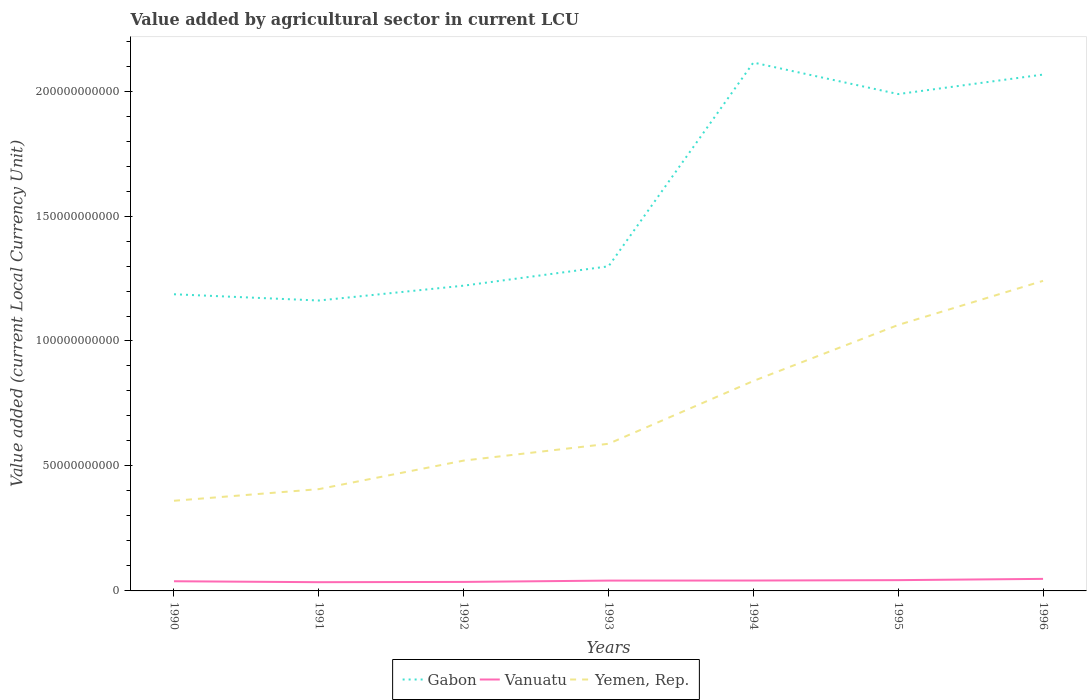Does the line corresponding to Vanuatu intersect with the line corresponding to Gabon?
Make the answer very short. No. Across all years, what is the maximum value added by agricultural sector in Vanuatu?
Give a very brief answer. 3.49e+09. What is the total value added by agricultural sector in Yemen, Rep. in the graph?
Offer a very short reply. -4.66e+09. What is the difference between the highest and the second highest value added by agricultural sector in Yemen, Rep.?
Offer a very short reply. 8.80e+1. What is the difference between the highest and the lowest value added by agricultural sector in Yemen, Rep.?
Make the answer very short. 3. Is the value added by agricultural sector in Gabon strictly greater than the value added by agricultural sector in Vanuatu over the years?
Your response must be concise. No. What is the difference between two consecutive major ticks on the Y-axis?
Provide a short and direct response. 5.00e+1. Are the values on the major ticks of Y-axis written in scientific E-notation?
Your answer should be compact. No. Does the graph contain grids?
Your answer should be compact. No. How are the legend labels stacked?
Offer a terse response. Horizontal. What is the title of the graph?
Provide a succinct answer. Value added by agricultural sector in current LCU. Does "Macedonia" appear as one of the legend labels in the graph?
Give a very brief answer. No. What is the label or title of the Y-axis?
Your response must be concise. Value added (current Local Currency Unit). What is the Value added (current Local Currency Unit) in Gabon in 1990?
Your response must be concise. 1.19e+11. What is the Value added (current Local Currency Unit) of Vanuatu in 1990?
Offer a terse response. 3.87e+09. What is the Value added (current Local Currency Unit) of Yemen, Rep. in 1990?
Offer a very short reply. 3.61e+1. What is the Value added (current Local Currency Unit) of Gabon in 1991?
Offer a terse response. 1.16e+11. What is the Value added (current Local Currency Unit) in Vanuatu in 1991?
Your answer should be compact. 3.49e+09. What is the Value added (current Local Currency Unit) in Yemen, Rep. in 1991?
Ensure brevity in your answer.  4.07e+1. What is the Value added (current Local Currency Unit) in Gabon in 1992?
Keep it short and to the point. 1.22e+11. What is the Value added (current Local Currency Unit) of Vanuatu in 1992?
Offer a terse response. 3.60e+09. What is the Value added (current Local Currency Unit) of Yemen, Rep. in 1992?
Provide a succinct answer. 5.21e+1. What is the Value added (current Local Currency Unit) in Gabon in 1993?
Ensure brevity in your answer.  1.30e+11. What is the Value added (current Local Currency Unit) of Vanuatu in 1993?
Give a very brief answer. 4.13e+09. What is the Value added (current Local Currency Unit) in Yemen, Rep. in 1993?
Keep it short and to the point. 5.89e+1. What is the Value added (current Local Currency Unit) of Gabon in 1994?
Give a very brief answer. 2.11e+11. What is the Value added (current Local Currency Unit) of Vanuatu in 1994?
Provide a succinct answer. 4.16e+09. What is the Value added (current Local Currency Unit) in Yemen, Rep. in 1994?
Keep it short and to the point. 8.40e+1. What is the Value added (current Local Currency Unit) in Gabon in 1995?
Your answer should be compact. 1.99e+11. What is the Value added (current Local Currency Unit) in Vanuatu in 1995?
Give a very brief answer. 4.31e+09. What is the Value added (current Local Currency Unit) in Yemen, Rep. in 1995?
Your response must be concise. 1.06e+11. What is the Value added (current Local Currency Unit) of Gabon in 1996?
Your answer should be very brief. 2.07e+11. What is the Value added (current Local Currency Unit) in Vanuatu in 1996?
Ensure brevity in your answer.  4.82e+09. What is the Value added (current Local Currency Unit) of Yemen, Rep. in 1996?
Your response must be concise. 1.24e+11. Across all years, what is the maximum Value added (current Local Currency Unit) of Gabon?
Offer a very short reply. 2.11e+11. Across all years, what is the maximum Value added (current Local Currency Unit) of Vanuatu?
Offer a terse response. 4.82e+09. Across all years, what is the maximum Value added (current Local Currency Unit) of Yemen, Rep.?
Keep it short and to the point. 1.24e+11. Across all years, what is the minimum Value added (current Local Currency Unit) in Gabon?
Ensure brevity in your answer.  1.16e+11. Across all years, what is the minimum Value added (current Local Currency Unit) of Vanuatu?
Offer a terse response. 3.49e+09. Across all years, what is the minimum Value added (current Local Currency Unit) in Yemen, Rep.?
Make the answer very short. 3.61e+1. What is the total Value added (current Local Currency Unit) of Gabon in the graph?
Provide a succinct answer. 1.10e+12. What is the total Value added (current Local Currency Unit) in Vanuatu in the graph?
Offer a terse response. 2.84e+1. What is the total Value added (current Local Currency Unit) of Yemen, Rep. in the graph?
Keep it short and to the point. 5.02e+11. What is the difference between the Value added (current Local Currency Unit) in Gabon in 1990 and that in 1991?
Your answer should be compact. 2.50e+09. What is the difference between the Value added (current Local Currency Unit) in Vanuatu in 1990 and that in 1991?
Make the answer very short. 3.78e+08. What is the difference between the Value added (current Local Currency Unit) in Yemen, Rep. in 1990 and that in 1991?
Your answer should be very brief. -4.66e+09. What is the difference between the Value added (current Local Currency Unit) in Gabon in 1990 and that in 1992?
Your answer should be compact. -3.44e+09. What is the difference between the Value added (current Local Currency Unit) in Vanuatu in 1990 and that in 1992?
Offer a very short reply. 2.68e+08. What is the difference between the Value added (current Local Currency Unit) in Yemen, Rep. in 1990 and that in 1992?
Provide a short and direct response. -1.61e+1. What is the difference between the Value added (current Local Currency Unit) in Gabon in 1990 and that in 1993?
Provide a succinct answer. -1.12e+1. What is the difference between the Value added (current Local Currency Unit) of Vanuatu in 1990 and that in 1993?
Keep it short and to the point. -2.62e+08. What is the difference between the Value added (current Local Currency Unit) in Yemen, Rep. in 1990 and that in 1993?
Offer a very short reply. -2.28e+1. What is the difference between the Value added (current Local Currency Unit) of Gabon in 1990 and that in 1994?
Your response must be concise. -9.27e+1. What is the difference between the Value added (current Local Currency Unit) of Vanuatu in 1990 and that in 1994?
Offer a terse response. -2.85e+08. What is the difference between the Value added (current Local Currency Unit) of Yemen, Rep. in 1990 and that in 1994?
Offer a terse response. -4.79e+1. What is the difference between the Value added (current Local Currency Unit) in Gabon in 1990 and that in 1995?
Your answer should be very brief. -8.01e+1. What is the difference between the Value added (current Local Currency Unit) in Vanuatu in 1990 and that in 1995?
Ensure brevity in your answer.  -4.41e+08. What is the difference between the Value added (current Local Currency Unit) of Yemen, Rep. in 1990 and that in 1995?
Give a very brief answer. -7.03e+1. What is the difference between the Value added (current Local Currency Unit) in Gabon in 1990 and that in 1996?
Provide a succinct answer. -8.79e+1. What is the difference between the Value added (current Local Currency Unit) in Vanuatu in 1990 and that in 1996?
Provide a short and direct response. -9.50e+08. What is the difference between the Value added (current Local Currency Unit) of Yemen, Rep. in 1990 and that in 1996?
Ensure brevity in your answer.  -8.80e+1. What is the difference between the Value added (current Local Currency Unit) of Gabon in 1991 and that in 1992?
Offer a terse response. -5.94e+09. What is the difference between the Value added (current Local Currency Unit) in Vanuatu in 1991 and that in 1992?
Your answer should be compact. -1.10e+08. What is the difference between the Value added (current Local Currency Unit) of Yemen, Rep. in 1991 and that in 1992?
Give a very brief answer. -1.14e+1. What is the difference between the Value added (current Local Currency Unit) in Gabon in 1991 and that in 1993?
Your answer should be very brief. -1.37e+1. What is the difference between the Value added (current Local Currency Unit) of Vanuatu in 1991 and that in 1993?
Give a very brief answer. -6.40e+08. What is the difference between the Value added (current Local Currency Unit) of Yemen, Rep. in 1991 and that in 1993?
Provide a succinct answer. -1.81e+1. What is the difference between the Value added (current Local Currency Unit) in Gabon in 1991 and that in 1994?
Your response must be concise. -9.52e+1. What is the difference between the Value added (current Local Currency Unit) of Vanuatu in 1991 and that in 1994?
Make the answer very short. -6.63e+08. What is the difference between the Value added (current Local Currency Unit) in Yemen, Rep. in 1991 and that in 1994?
Ensure brevity in your answer.  -4.33e+1. What is the difference between the Value added (current Local Currency Unit) in Gabon in 1991 and that in 1995?
Offer a very short reply. -8.26e+1. What is the difference between the Value added (current Local Currency Unit) of Vanuatu in 1991 and that in 1995?
Ensure brevity in your answer.  -8.19e+08. What is the difference between the Value added (current Local Currency Unit) of Yemen, Rep. in 1991 and that in 1995?
Offer a terse response. -6.57e+1. What is the difference between the Value added (current Local Currency Unit) of Gabon in 1991 and that in 1996?
Keep it short and to the point. -9.04e+1. What is the difference between the Value added (current Local Currency Unit) of Vanuatu in 1991 and that in 1996?
Ensure brevity in your answer.  -1.33e+09. What is the difference between the Value added (current Local Currency Unit) of Yemen, Rep. in 1991 and that in 1996?
Your answer should be compact. -8.33e+1. What is the difference between the Value added (current Local Currency Unit) in Gabon in 1992 and that in 1993?
Provide a succinct answer. -7.74e+09. What is the difference between the Value added (current Local Currency Unit) in Vanuatu in 1992 and that in 1993?
Offer a very short reply. -5.30e+08. What is the difference between the Value added (current Local Currency Unit) of Yemen, Rep. in 1992 and that in 1993?
Your answer should be compact. -6.73e+09. What is the difference between the Value added (current Local Currency Unit) in Gabon in 1992 and that in 1994?
Your answer should be compact. -8.93e+1. What is the difference between the Value added (current Local Currency Unit) in Vanuatu in 1992 and that in 1994?
Provide a short and direct response. -5.53e+08. What is the difference between the Value added (current Local Currency Unit) in Yemen, Rep. in 1992 and that in 1994?
Provide a succinct answer. -3.19e+1. What is the difference between the Value added (current Local Currency Unit) in Gabon in 1992 and that in 1995?
Provide a short and direct response. -7.67e+1. What is the difference between the Value added (current Local Currency Unit) of Vanuatu in 1992 and that in 1995?
Make the answer very short. -7.09e+08. What is the difference between the Value added (current Local Currency Unit) in Yemen, Rep. in 1992 and that in 1995?
Your answer should be compact. -5.43e+1. What is the difference between the Value added (current Local Currency Unit) in Gabon in 1992 and that in 1996?
Keep it short and to the point. -8.45e+1. What is the difference between the Value added (current Local Currency Unit) in Vanuatu in 1992 and that in 1996?
Make the answer very short. -1.22e+09. What is the difference between the Value added (current Local Currency Unit) of Yemen, Rep. in 1992 and that in 1996?
Give a very brief answer. -7.19e+1. What is the difference between the Value added (current Local Currency Unit) of Gabon in 1993 and that in 1994?
Your answer should be very brief. -8.15e+1. What is the difference between the Value added (current Local Currency Unit) in Vanuatu in 1993 and that in 1994?
Make the answer very short. -2.30e+07. What is the difference between the Value added (current Local Currency Unit) of Yemen, Rep. in 1993 and that in 1994?
Offer a very short reply. -2.51e+1. What is the difference between the Value added (current Local Currency Unit) in Gabon in 1993 and that in 1995?
Offer a very short reply. -6.89e+1. What is the difference between the Value added (current Local Currency Unit) of Vanuatu in 1993 and that in 1995?
Offer a very short reply. -1.79e+08. What is the difference between the Value added (current Local Currency Unit) in Yemen, Rep. in 1993 and that in 1995?
Give a very brief answer. -4.75e+1. What is the difference between the Value added (current Local Currency Unit) of Gabon in 1993 and that in 1996?
Give a very brief answer. -7.67e+1. What is the difference between the Value added (current Local Currency Unit) of Vanuatu in 1993 and that in 1996?
Make the answer very short. -6.88e+08. What is the difference between the Value added (current Local Currency Unit) of Yemen, Rep. in 1993 and that in 1996?
Keep it short and to the point. -6.52e+1. What is the difference between the Value added (current Local Currency Unit) of Gabon in 1994 and that in 1995?
Offer a terse response. 1.26e+1. What is the difference between the Value added (current Local Currency Unit) in Vanuatu in 1994 and that in 1995?
Give a very brief answer. -1.56e+08. What is the difference between the Value added (current Local Currency Unit) of Yemen, Rep. in 1994 and that in 1995?
Give a very brief answer. -2.24e+1. What is the difference between the Value added (current Local Currency Unit) in Gabon in 1994 and that in 1996?
Provide a succinct answer. 4.81e+09. What is the difference between the Value added (current Local Currency Unit) of Vanuatu in 1994 and that in 1996?
Provide a short and direct response. -6.65e+08. What is the difference between the Value added (current Local Currency Unit) in Yemen, Rep. in 1994 and that in 1996?
Give a very brief answer. -4.01e+1. What is the difference between the Value added (current Local Currency Unit) of Gabon in 1995 and that in 1996?
Ensure brevity in your answer.  -7.80e+09. What is the difference between the Value added (current Local Currency Unit) of Vanuatu in 1995 and that in 1996?
Make the answer very short. -5.09e+08. What is the difference between the Value added (current Local Currency Unit) of Yemen, Rep. in 1995 and that in 1996?
Ensure brevity in your answer.  -1.76e+1. What is the difference between the Value added (current Local Currency Unit) in Gabon in 1990 and the Value added (current Local Currency Unit) in Vanuatu in 1991?
Your answer should be very brief. 1.15e+11. What is the difference between the Value added (current Local Currency Unit) of Gabon in 1990 and the Value added (current Local Currency Unit) of Yemen, Rep. in 1991?
Keep it short and to the point. 7.80e+1. What is the difference between the Value added (current Local Currency Unit) of Vanuatu in 1990 and the Value added (current Local Currency Unit) of Yemen, Rep. in 1991?
Give a very brief answer. -3.69e+1. What is the difference between the Value added (current Local Currency Unit) of Gabon in 1990 and the Value added (current Local Currency Unit) of Vanuatu in 1992?
Keep it short and to the point. 1.15e+11. What is the difference between the Value added (current Local Currency Unit) of Gabon in 1990 and the Value added (current Local Currency Unit) of Yemen, Rep. in 1992?
Give a very brief answer. 6.66e+1. What is the difference between the Value added (current Local Currency Unit) of Vanuatu in 1990 and the Value added (current Local Currency Unit) of Yemen, Rep. in 1992?
Give a very brief answer. -4.83e+1. What is the difference between the Value added (current Local Currency Unit) of Gabon in 1990 and the Value added (current Local Currency Unit) of Vanuatu in 1993?
Your answer should be compact. 1.15e+11. What is the difference between the Value added (current Local Currency Unit) in Gabon in 1990 and the Value added (current Local Currency Unit) in Yemen, Rep. in 1993?
Your answer should be very brief. 5.98e+1. What is the difference between the Value added (current Local Currency Unit) in Vanuatu in 1990 and the Value added (current Local Currency Unit) in Yemen, Rep. in 1993?
Provide a short and direct response. -5.50e+1. What is the difference between the Value added (current Local Currency Unit) in Gabon in 1990 and the Value added (current Local Currency Unit) in Vanuatu in 1994?
Give a very brief answer. 1.15e+11. What is the difference between the Value added (current Local Currency Unit) in Gabon in 1990 and the Value added (current Local Currency Unit) in Yemen, Rep. in 1994?
Your answer should be compact. 3.47e+1. What is the difference between the Value added (current Local Currency Unit) in Vanuatu in 1990 and the Value added (current Local Currency Unit) in Yemen, Rep. in 1994?
Give a very brief answer. -8.01e+1. What is the difference between the Value added (current Local Currency Unit) in Gabon in 1990 and the Value added (current Local Currency Unit) in Vanuatu in 1995?
Offer a terse response. 1.14e+11. What is the difference between the Value added (current Local Currency Unit) of Gabon in 1990 and the Value added (current Local Currency Unit) of Yemen, Rep. in 1995?
Provide a succinct answer. 1.23e+1. What is the difference between the Value added (current Local Currency Unit) in Vanuatu in 1990 and the Value added (current Local Currency Unit) in Yemen, Rep. in 1995?
Ensure brevity in your answer.  -1.03e+11. What is the difference between the Value added (current Local Currency Unit) in Gabon in 1990 and the Value added (current Local Currency Unit) in Vanuatu in 1996?
Your response must be concise. 1.14e+11. What is the difference between the Value added (current Local Currency Unit) in Gabon in 1990 and the Value added (current Local Currency Unit) in Yemen, Rep. in 1996?
Your answer should be very brief. -5.37e+09. What is the difference between the Value added (current Local Currency Unit) in Vanuatu in 1990 and the Value added (current Local Currency Unit) in Yemen, Rep. in 1996?
Offer a very short reply. -1.20e+11. What is the difference between the Value added (current Local Currency Unit) of Gabon in 1991 and the Value added (current Local Currency Unit) of Vanuatu in 1992?
Offer a very short reply. 1.13e+11. What is the difference between the Value added (current Local Currency Unit) in Gabon in 1991 and the Value added (current Local Currency Unit) in Yemen, Rep. in 1992?
Provide a short and direct response. 6.41e+1. What is the difference between the Value added (current Local Currency Unit) in Vanuatu in 1991 and the Value added (current Local Currency Unit) in Yemen, Rep. in 1992?
Your response must be concise. -4.87e+1. What is the difference between the Value added (current Local Currency Unit) of Gabon in 1991 and the Value added (current Local Currency Unit) of Vanuatu in 1993?
Offer a terse response. 1.12e+11. What is the difference between the Value added (current Local Currency Unit) in Gabon in 1991 and the Value added (current Local Currency Unit) in Yemen, Rep. in 1993?
Provide a short and direct response. 5.73e+1. What is the difference between the Value added (current Local Currency Unit) of Vanuatu in 1991 and the Value added (current Local Currency Unit) of Yemen, Rep. in 1993?
Your answer should be compact. -5.54e+1. What is the difference between the Value added (current Local Currency Unit) in Gabon in 1991 and the Value added (current Local Currency Unit) in Vanuatu in 1994?
Provide a succinct answer. 1.12e+11. What is the difference between the Value added (current Local Currency Unit) in Gabon in 1991 and the Value added (current Local Currency Unit) in Yemen, Rep. in 1994?
Your answer should be compact. 3.22e+1. What is the difference between the Value added (current Local Currency Unit) in Vanuatu in 1991 and the Value added (current Local Currency Unit) in Yemen, Rep. in 1994?
Provide a succinct answer. -8.05e+1. What is the difference between the Value added (current Local Currency Unit) in Gabon in 1991 and the Value added (current Local Currency Unit) in Vanuatu in 1995?
Your response must be concise. 1.12e+11. What is the difference between the Value added (current Local Currency Unit) in Gabon in 1991 and the Value added (current Local Currency Unit) in Yemen, Rep. in 1995?
Make the answer very short. 9.78e+09. What is the difference between the Value added (current Local Currency Unit) in Vanuatu in 1991 and the Value added (current Local Currency Unit) in Yemen, Rep. in 1995?
Provide a succinct answer. -1.03e+11. What is the difference between the Value added (current Local Currency Unit) in Gabon in 1991 and the Value added (current Local Currency Unit) in Vanuatu in 1996?
Ensure brevity in your answer.  1.11e+11. What is the difference between the Value added (current Local Currency Unit) in Gabon in 1991 and the Value added (current Local Currency Unit) in Yemen, Rep. in 1996?
Ensure brevity in your answer.  -7.87e+09. What is the difference between the Value added (current Local Currency Unit) in Vanuatu in 1991 and the Value added (current Local Currency Unit) in Yemen, Rep. in 1996?
Offer a terse response. -1.21e+11. What is the difference between the Value added (current Local Currency Unit) in Gabon in 1992 and the Value added (current Local Currency Unit) in Vanuatu in 1993?
Offer a very short reply. 1.18e+11. What is the difference between the Value added (current Local Currency Unit) of Gabon in 1992 and the Value added (current Local Currency Unit) of Yemen, Rep. in 1993?
Offer a very short reply. 6.33e+1. What is the difference between the Value added (current Local Currency Unit) of Vanuatu in 1992 and the Value added (current Local Currency Unit) of Yemen, Rep. in 1993?
Make the answer very short. -5.53e+1. What is the difference between the Value added (current Local Currency Unit) of Gabon in 1992 and the Value added (current Local Currency Unit) of Vanuatu in 1994?
Your answer should be compact. 1.18e+11. What is the difference between the Value added (current Local Currency Unit) of Gabon in 1992 and the Value added (current Local Currency Unit) of Yemen, Rep. in 1994?
Offer a terse response. 3.81e+1. What is the difference between the Value added (current Local Currency Unit) of Vanuatu in 1992 and the Value added (current Local Currency Unit) of Yemen, Rep. in 1994?
Your answer should be compact. -8.04e+1. What is the difference between the Value added (current Local Currency Unit) in Gabon in 1992 and the Value added (current Local Currency Unit) in Vanuatu in 1995?
Your response must be concise. 1.18e+11. What is the difference between the Value added (current Local Currency Unit) of Gabon in 1992 and the Value added (current Local Currency Unit) of Yemen, Rep. in 1995?
Your answer should be compact. 1.57e+1. What is the difference between the Value added (current Local Currency Unit) in Vanuatu in 1992 and the Value added (current Local Currency Unit) in Yemen, Rep. in 1995?
Your answer should be compact. -1.03e+11. What is the difference between the Value added (current Local Currency Unit) in Gabon in 1992 and the Value added (current Local Currency Unit) in Vanuatu in 1996?
Give a very brief answer. 1.17e+11. What is the difference between the Value added (current Local Currency Unit) in Gabon in 1992 and the Value added (current Local Currency Unit) in Yemen, Rep. in 1996?
Keep it short and to the point. -1.92e+09. What is the difference between the Value added (current Local Currency Unit) in Vanuatu in 1992 and the Value added (current Local Currency Unit) in Yemen, Rep. in 1996?
Offer a terse response. -1.20e+11. What is the difference between the Value added (current Local Currency Unit) in Gabon in 1993 and the Value added (current Local Currency Unit) in Vanuatu in 1994?
Your answer should be compact. 1.26e+11. What is the difference between the Value added (current Local Currency Unit) in Gabon in 1993 and the Value added (current Local Currency Unit) in Yemen, Rep. in 1994?
Keep it short and to the point. 4.59e+1. What is the difference between the Value added (current Local Currency Unit) of Vanuatu in 1993 and the Value added (current Local Currency Unit) of Yemen, Rep. in 1994?
Ensure brevity in your answer.  -7.99e+1. What is the difference between the Value added (current Local Currency Unit) of Gabon in 1993 and the Value added (current Local Currency Unit) of Vanuatu in 1995?
Offer a terse response. 1.26e+11. What is the difference between the Value added (current Local Currency Unit) of Gabon in 1993 and the Value added (current Local Currency Unit) of Yemen, Rep. in 1995?
Your answer should be very brief. 2.35e+1. What is the difference between the Value added (current Local Currency Unit) of Vanuatu in 1993 and the Value added (current Local Currency Unit) of Yemen, Rep. in 1995?
Offer a terse response. -1.02e+11. What is the difference between the Value added (current Local Currency Unit) of Gabon in 1993 and the Value added (current Local Currency Unit) of Vanuatu in 1996?
Give a very brief answer. 1.25e+11. What is the difference between the Value added (current Local Currency Unit) of Gabon in 1993 and the Value added (current Local Currency Unit) of Yemen, Rep. in 1996?
Your response must be concise. 5.81e+09. What is the difference between the Value added (current Local Currency Unit) of Vanuatu in 1993 and the Value added (current Local Currency Unit) of Yemen, Rep. in 1996?
Your answer should be compact. -1.20e+11. What is the difference between the Value added (current Local Currency Unit) in Gabon in 1994 and the Value added (current Local Currency Unit) in Vanuatu in 1995?
Keep it short and to the point. 2.07e+11. What is the difference between the Value added (current Local Currency Unit) in Gabon in 1994 and the Value added (current Local Currency Unit) in Yemen, Rep. in 1995?
Give a very brief answer. 1.05e+11. What is the difference between the Value added (current Local Currency Unit) in Vanuatu in 1994 and the Value added (current Local Currency Unit) in Yemen, Rep. in 1995?
Provide a short and direct response. -1.02e+11. What is the difference between the Value added (current Local Currency Unit) of Gabon in 1994 and the Value added (current Local Currency Unit) of Vanuatu in 1996?
Give a very brief answer. 2.07e+11. What is the difference between the Value added (current Local Currency Unit) in Gabon in 1994 and the Value added (current Local Currency Unit) in Yemen, Rep. in 1996?
Your response must be concise. 8.73e+1. What is the difference between the Value added (current Local Currency Unit) of Vanuatu in 1994 and the Value added (current Local Currency Unit) of Yemen, Rep. in 1996?
Give a very brief answer. -1.20e+11. What is the difference between the Value added (current Local Currency Unit) in Gabon in 1995 and the Value added (current Local Currency Unit) in Vanuatu in 1996?
Your answer should be very brief. 1.94e+11. What is the difference between the Value added (current Local Currency Unit) of Gabon in 1995 and the Value added (current Local Currency Unit) of Yemen, Rep. in 1996?
Your answer should be compact. 7.47e+1. What is the difference between the Value added (current Local Currency Unit) of Vanuatu in 1995 and the Value added (current Local Currency Unit) of Yemen, Rep. in 1996?
Give a very brief answer. -1.20e+11. What is the average Value added (current Local Currency Unit) in Gabon per year?
Your answer should be very brief. 1.58e+11. What is the average Value added (current Local Currency Unit) in Vanuatu per year?
Provide a short and direct response. 4.06e+09. What is the average Value added (current Local Currency Unit) of Yemen, Rep. per year?
Offer a terse response. 7.18e+1. In the year 1990, what is the difference between the Value added (current Local Currency Unit) in Gabon and Value added (current Local Currency Unit) in Vanuatu?
Offer a very short reply. 1.15e+11. In the year 1990, what is the difference between the Value added (current Local Currency Unit) in Gabon and Value added (current Local Currency Unit) in Yemen, Rep.?
Your answer should be very brief. 8.26e+1. In the year 1990, what is the difference between the Value added (current Local Currency Unit) in Vanuatu and Value added (current Local Currency Unit) in Yemen, Rep.?
Offer a terse response. -3.22e+1. In the year 1991, what is the difference between the Value added (current Local Currency Unit) of Gabon and Value added (current Local Currency Unit) of Vanuatu?
Ensure brevity in your answer.  1.13e+11. In the year 1991, what is the difference between the Value added (current Local Currency Unit) of Gabon and Value added (current Local Currency Unit) of Yemen, Rep.?
Your response must be concise. 7.55e+1. In the year 1991, what is the difference between the Value added (current Local Currency Unit) in Vanuatu and Value added (current Local Currency Unit) in Yemen, Rep.?
Offer a terse response. -3.72e+1. In the year 1992, what is the difference between the Value added (current Local Currency Unit) in Gabon and Value added (current Local Currency Unit) in Vanuatu?
Give a very brief answer. 1.19e+11. In the year 1992, what is the difference between the Value added (current Local Currency Unit) in Gabon and Value added (current Local Currency Unit) in Yemen, Rep.?
Make the answer very short. 7.00e+1. In the year 1992, what is the difference between the Value added (current Local Currency Unit) of Vanuatu and Value added (current Local Currency Unit) of Yemen, Rep.?
Offer a terse response. -4.85e+1. In the year 1993, what is the difference between the Value added (current Local Currency Unit) in Gabon and Value added (current Local Currency Unit) in Vanuatu?
Offer a very short reply. 1.26e+11. In the year 1993, what is the difference between the Value added (current Local Currency Unit) in Gabon and Value added (current Local Currency Unit) in Yemen, Rep.?
Your answer should be compact. 7.10e+1. In the year 1993, what is the difference between the Value added (current Local Currency Unit) of Vanuatu and Value added (current Local Currency Unit) of Yemen, Rep.?
Ensure brevity in your answer.  -5.47e+1. In the year 1994, what is the difference between the Value added (current Local Currency Unit) in Gabon and Value added (current Local Currency Unit) in Vanuatu?
Offer a very short reply. 2.07e+11. In the year 1994, what is the difference between the Value added (current Local Currency Unit) in Gabon and Value added (current Local Currency Unit) in Yemen, Rep.?
Offer a terse response. 1.27e+11. In the year 1994, what is the difference between the Value added (current Local Currency Unit) of Vanuatu and Value added (current Local Currency Unit) of Yemen, Rep.?
Your response must be concise. -7.98e+1. In the year 1995, what is the difference between the Value added (current Local Currency Unit) in Gabon and Value added (current Local Currency Unit) in Vanuatu?
Keep it short and to the point. 1.94e+11. In the year 1995, what is the difference between the Value added (current Local Currency Unit) of Gabon and Value added (current Local Currency Unit) of Yemen, Rep.?
Keep it short and to the point. 9.24e+1. In the year 1995, what is the difference between the Value added (current Local Currency Unit) of Vanuatu and Value added (current Local Currency Unit) of Yemen, Rep.?
Keep it short and to the point. -1.02e+11. In the year 1996, what is the difference between the Value added (current Local Currency Unit) of Gabon and Value added (current Local Currency Unit) of Vanuatu?
Your response must be concise. 2.02e+11. In the year 1996, what is the difference between the Value added (current Local Currency Unit) of Gabon and Value added (current Local Currency Unit) of Yemen, Rep.?
Your answer should be compact. 8.25e+1. In the year 1996, what is the difference between the Value added (current Local Currency Unit) in Vanuatu and Value added (current Local Currency Unit) in Yemen, Rep.?
Give a very brief answer. -1.19e+11. What is the ratio of the Value added (current Local Currency Unit) of Gabon in 1990 to that in 1991?
Keep it short and to the point. 1.02. What is the ratio of the Value added (current Local Currency Unit) of Vanuatu in 1990 to that in 1991?
Give a very brief answer. 1.11. What is the ratio of the Value added (current Local Currency Unit) in Yemen, Rep. in 1990 to that in 1991?
Your response must be concise. 0.89. What is the ratio of the Value added (current Local Currency Unit) of Gabon in 1990 to that in 1992?
Ensure brevity in your answer.  0.97. What is the ratio of the Value added (current Local Currency Unit) in Vanuatu in 1990 to that in 1992?
Keep it short and to the point. 1.07. What is the ratio of the Value added (current Local Currency Unit) in Yemen, Rep. in 1990 to that in 1992?
Ensure brevity in your answer.  0.69. What is the ratio of the Value added (current Local Currency Unit) in Gabon in 1990 to that in 1993?
Give a very brief answer. 0.91. What is the ratio of the Value added (current Local Currency Unit) in Vanuatu in 1990 to that in 1993?
Keep it short and to the point. 0.94. What is the ratio of the Value added (current Local Currency Unit) of Yemen, Rep. in 1990 to that in 1993?
Provide a succinct answer. 0.61. What is the ratio of the Value added (current Local Currency Unit) of Gabon in 1990 to that in 1994?
Make the answer very short. 0.56. What is the ratio of the Value added (current Local Currency Unit) in Vanuatu in 1990 to that in 1994?
Offer a terse response. 0.93. What is the ratio of the Value added (current Local Currency Unit) in Yemen, Rep. in 1990 to that in 1994?
Keep it short and to the point. 0.43. What is the ratio of the Value added (current Local Currency Unit) in Gabon in 1990 to that in 1995?
Your response must be concise. 0.6. What is the ratio of the Value added (current Local Currency Unit) of Vanuatu in 1990 to that in 1995?
Ensure brevity in your answer.  0.9. What is the ratio of the Value added (current Local Currency Unit) in Yemen, Rep. in 1990 to that in 1995?
Ensure brevity in your answer.  0.34. What is the ratio of the Value added (current Local Currency Unit) of Gabon in 1990 to that in 1996?
Make the answer very short. 0.57. What is the ratio of the Value added (current Local Currency Unit) of Vanuatu in 1990 to that in 1996?
Ensure brevity in your answer.  0.8. What is the ratio of the Value added (current Local Currency Unit) of Yemen, Rep. in 1990 to that in 1996?
Give a very brief answer. 0.29. What is the ratio of the Value added (current Local Currency Unit) of Gabon in 1991 to that in 1992?
Provide a succinct answer. 0.95. What is the ratio of the Value added (current Local Currency Unit) of Vanuatu in 1991 to that in 1992?
Make the answer very short. 0.97. What is the ratio of the Value added (current Local Currency Unit) of Yemen, Rep. in 1991 to that in 1992?
Your response must be concise. 0.78. What is the ratio of the Value added (current Local Currency Unit) in Gabon in 1991 to that in 1993?
Your answer should be very brief. 0.89. What is the ratio of the Value added (current Local Currency Unit) in Vanuatu in 1991 to that in 1993?
Keep it short and to the point. 0.85. What is the ratio of the Value added (current Local Currency Unit) of Yemen, Rep. in 1991 to that in 1993?
Offer a terse response. 0.69. What is the ratio of the Value added (current Local Currency Unit) in Gabon in 1991 to that in 1994?
Give a very brief answer. 0.55. What is the ratio of the Value added (current Local Currency Unit) in Vanuatu in 1991 to that in 1994?
Offer a terse response. 0.84. What is the ratio of the Value added (current Local Currency Unit) of Yemen, Rep. in 1991 to that in 1994?
Your answer should be very brief. 0.48. What is the ratio of the Value added (current Local Currency Unit) in Gabon in 1991 to that in 1995?
Offer a very short reply. 0.58. What is the ratio of the Value added (current Local Currency Unit) of Vanuatu in 1991 to that in 1995?
Your answer should be very brief. 0.81. What is the ratio of the Value added (current Local Currency Unit) of Yemen, Rep. in 1991 to that in 1995?
Provide a short and direct response. 0.38. What is the ratio of the Value added (current Local Currency Unit) in Gabon in 1991 to that in 1996?
Provide a succinct answer. 0.56. What is the ratio of the Value added (current Local Currency Unit) in Vanuatu in 1991 to that in 1996?
Your response must be concise. 0.72. What is the ratio of the Value added (current Local Currency Unit) of Yemen, Rep. in 1991 to that in 1996?
Offer a terse response. 0.33. What is the ratio of the Value added (current Local Currency Unit) of Gabon in 1992 to that in 1993?
Ensure brevity in your answer.  0.94. What is the ratio of the Value added (current Local Currency Unit) of Vanuatu in 1992 to that in 1993?
Your response must be concise. 0.87. What is the ratio of the Value added (current Local Currency Unit) of Yemen, Rep. in 1992 to that in 1993?
Provide a short and direct response. 0.89. What is the ratio of the Value added (current Local Currency Unit) of Gabon in 1992 to that in 1994?
Ensure brevity in your answer.  0.58. What is the ratio of the Value added (current Local Currency Unit) in Vanuatu in 1992 to that in 1994?
Provide a succinct answer. 0.87. What is the ratio of the Value added (current Local Currency Unit) of Yemen, Rep. in 1992 to that in 1994?
Keep it short and to the point. 0.62. What is the ratio of the Value added (current Local Currency Unit) of Gabon in 1992 to that in 1995?
Offer a terse response. 0.61. What is the ratio of the Value added (current Local Currency Unit) in Vanuatu in 1992 to that in 1995?
Your response must be concise. 0.84. What is the ratio of the Value added (current Local Currency Unit) of Yemen, Rep. in 1992 to that in 1995?
Ensure brevity in your answer.  0.49. What is the ratio of the Value added (current Local Currency Unit) in Gabon in 1992 to that in 1996?
Offer a very short reply. 0.59. What is the ratio of the Value added (current Local Currency Unit) in Vanuatu in 1992 to that in 1996?
Offer a terse response. 0.75. What is the ratio of the Value added (current Local Currency Unit) of Yemen, Rep. in 1992 to that in 1996?
Ensure brevity in your answer.  0.42. What is the ratio of the Value added (current Local Currency Unit) in Gabon in 1993 to that in 1994?
Provide a succinct answer. 0.61. What is the ratio of the Value added (current Local Currency Unit) of Yemen, Rep. in 1993 to that in 1994?
Provide a short and direct response. 0.7. What is the ratio of the Value added (current Local Currency Unit) of Gabon in 1993 to that in 1995?
Keep it short and to the point. 0.65. What is the ratio of the Value added (current Local Currency Unit) in Vanuatu in 1993 to that in 1995?
Keep it short and to the point. 0.96. What is the ratio of the Value added (current Local Currency Unit) in Yemen, Rep. in 1993 to that in 1995?
Give a very brief answer. 0.55. What is the ratio of the Value added (current Local Currency Unit) in Gabon in 1993 to that in 1996?
Your response must be concise. 0.63. What is the ratio of the Value added (current Local Currency Unit) of Vanuatu in 1993 to that in 1996?
Your answer should be very brief. 0.86. What is the ratio of the Value added (current Local Currency Unit) of Yemen, Rep. in 1993 to that in 1996?
Make the answer very short. 0.47. What is the ratio of the Value added (current Local Currency Unit) of Gabon in 1994 to that in 1995?
Provide a short and direct response. 1.06. What is the ratio of the Value added (current Local Currency Unit) in Vanuatu in 1994 to that in 1995?
Your response must be concise. 0.96. What is the ratio of the Value added (current Local Currency Unit) in Yemen, Rep. in 1994 to that in 1995?
Make the answer very short. 0.79. What is the ratio of the Value added (current Local Currency Unit) in Gabon in 1994 to that in 1996?
Give a very brief answer. 1.02. What is the ratio of the Value added (current Local Currency Unit) of Vanuatu in 1994 to that in 1996?
Offer a terse response. 0.86. What is the ratio of the Value added (current Local Currency Unit) in Yemen, Rep. in 1994 to that in 1996?
Offer a very short reply. 0.68. What is the ratio of the Value added (current Local Currency Unit) of Gabon in 1995 to that in 1996?
Provide a short and direct response. 0.96. What is the ratio of the Value added (current Local Currency Unit) in Vanuatu in 1995 to that in 1996?
Ensure brevity in your answer.  0.89. What is the ratio of the Value added (current Local Currency Unit) of Yemen, Rep. in 1995 to that in 1996?
Make the answer very short. 0.86. What is the difference between the highest and the second highest Value added (current Local Currency Unit) in Gabon?
Your answer should be very brief. 4.81e+09. What is the difference between the highest and the second highest Value added (current Local Currency Unit) in Vanuatu?
Make the answer very short. 5.09e+08. What is the difference between the highest and the second highest Value added (current Local Currency Unit) of Yemen, Rep.?
Provide a succinct answer. 1.76e+1. What is the difference between the highest and the lowest Value added (current Local Currency Unit) in Gabon?
Your answer should be compact. 9.52e+1. What is the difference between the highest and the lowest Value added (current Local Currency Unit) of Vanuatu?
Provide a short and direct response. 1.33e+09. What is the difference between the highest and the lowest Value added (current Local Currency Unit) in Yemen, Rep.?
Keep it short and to the point. 8.80e+1. 